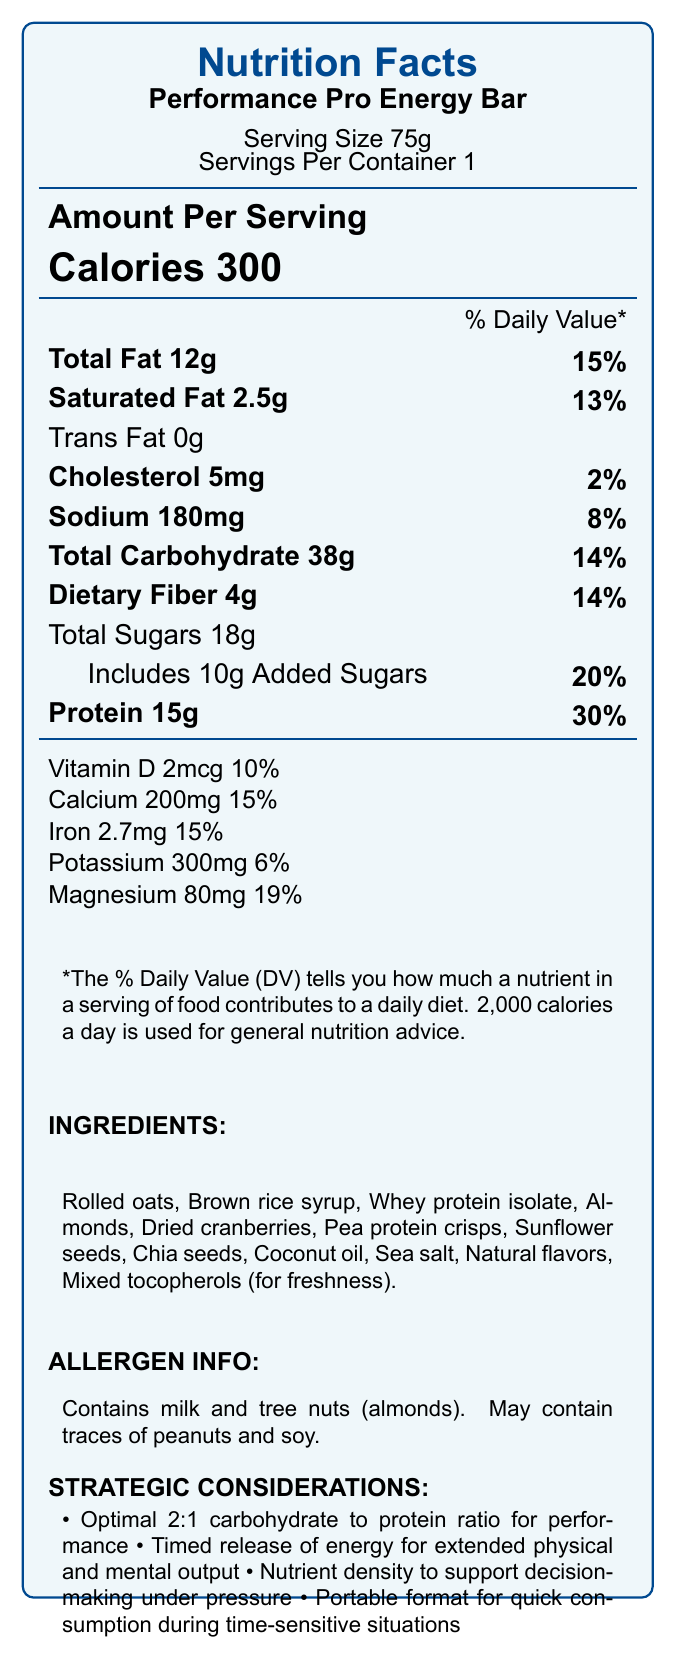what is the serving size of the Performance Pro Energy Bar? The serving size indicated in the upper portion of the nutrition facts label is 75g.
Answer: 75g how many calories are in one serving of the Performance Pro Energy Bar? The label states that there are 300 calories per serving.
Answer: 300 calories what is the total amount of fat per serving? The total fat per serving is listed as 12g in the nutrition facts.
Answer: 12g how much dietary fiber does the bar contain? The dietary fiber amount is 4g as stated on the label.
Answer: 4g how much protein is in one serving of the energy bar? The protein content per serving is 15g, as noted in the nutrition facts.
Answer: 15g how much vitamin D is included in one serving? The nutrition label states that there are 2mcg of vitamin D per serving.
Answer: 2mcg how much sodium does the bar contain? The sodium content per serving is 180mg, as indicated on the label.
Answer: 180mg which of the following nutrients has the highest Daily Value percentage? A. Vitamin D B. Calcium C. Dietary Fiber D. Protein The protein has the highest Daily Value percentage at 30%, according to the nutrition label.
Answer: D how much sugar is added to the energy bar? A. 8g B. 9g C. 10g D. 11g The label lists 10g of added sugars in the total sugars category.
Answer: C the bar provides a significant source of which mineral? A. Iron B. Magnesium C. Potassium D. Zinc The bar provides 19% of the Daily Value for Magnesium, which is significant compared to other listed minerals.
Answer: B is the Performance Pro Energy Bar suitable for someone with a peanut allergy? It may contain traces of peanuts and soy, as stated in the allergen information.
Answer: No summarize the main features of the Performance Pro Energy Bar. The document describes the key nutritional content and benefits of the energy bar, highlighting its purpose for high performance, balanced nutrition, and ease of use during athletic activities.
Answer: The Performance Pro Energy Bar provides 300 calories per 75g serving, with balanced macronutrient ratios including 12g of fat, 38g of carbohydrates, and 15g of protein. It also contains essential vitamins and minerals like vitamin D, calcium, iron, and magnesium. It emphasizes sustained energy, muscle recovery, and cognitive function, with strategic considerations for timed release of energy and portability. what is the main source of protein in the energy bar? The document lists various ingredients, but it does not specifically highlight which ingredient is the main source of protein.
Answer: Not enough information what are the two primary benefits of carbohydrates in this energy bar? The document mentions that complex carbohydrates support endurance and provide timed release of energy for extended physical and mental output.
Answer: Endurance and Timed release of energy 